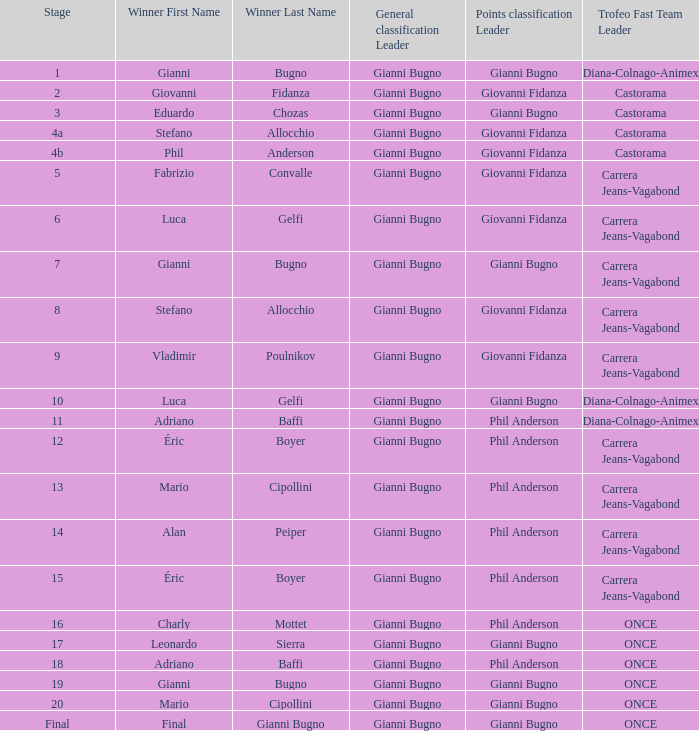Who is the winner when the trofeo fast team is carrera jeans-vagabond in stage 5? Fabrizio Convalle. 